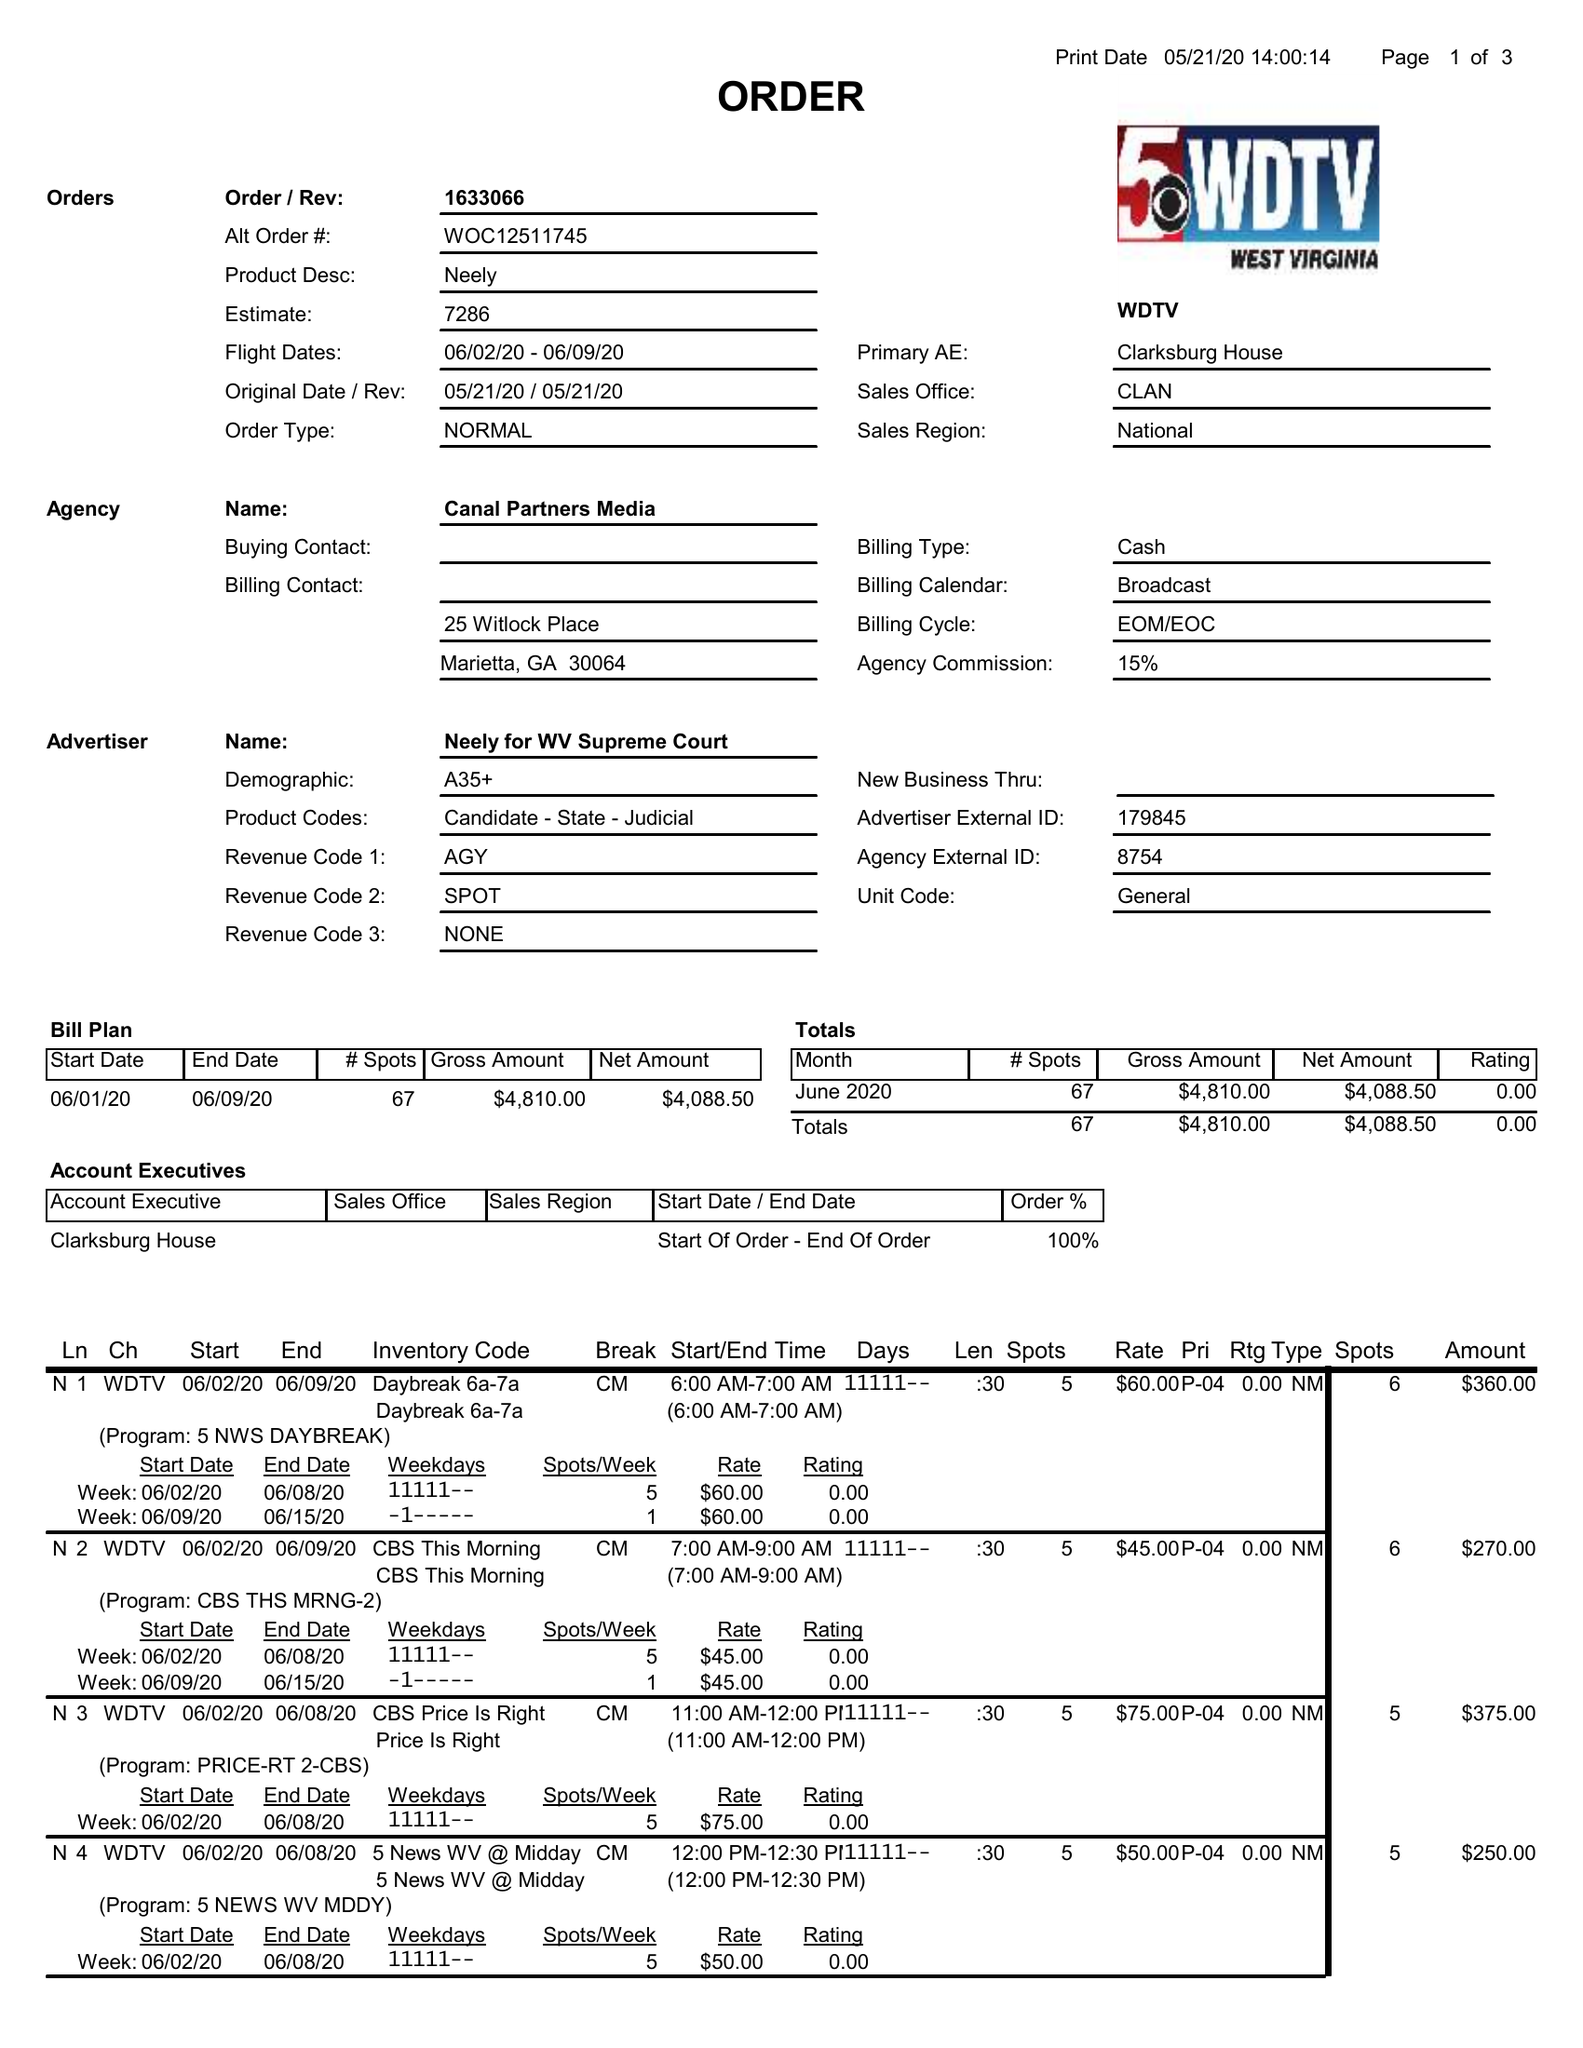What is the value for the flight_to?
Answer the question using a single word or phrase. 06/09/20 